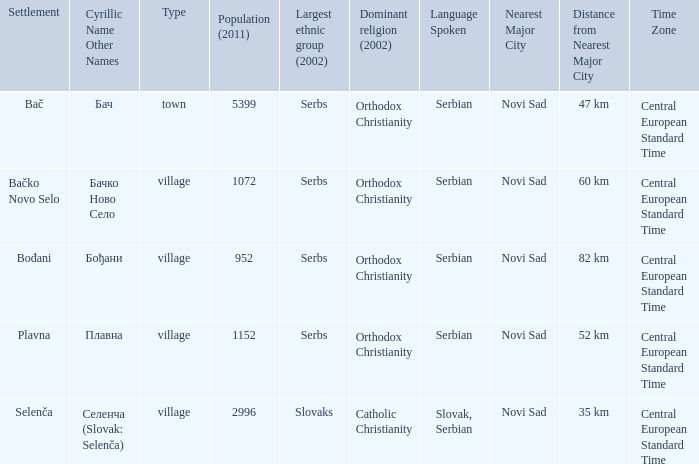What is the ethnic majority in the only town? Serbs. 